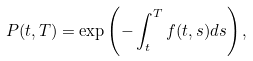Convert formula to latex. <formula><loc_0><loc_0><loc_500><loc_500>P ( t , T ) = \exp \left ( - \int _ { t } ^ { T } f ( t , s ) d s \right ) ,</formula> 